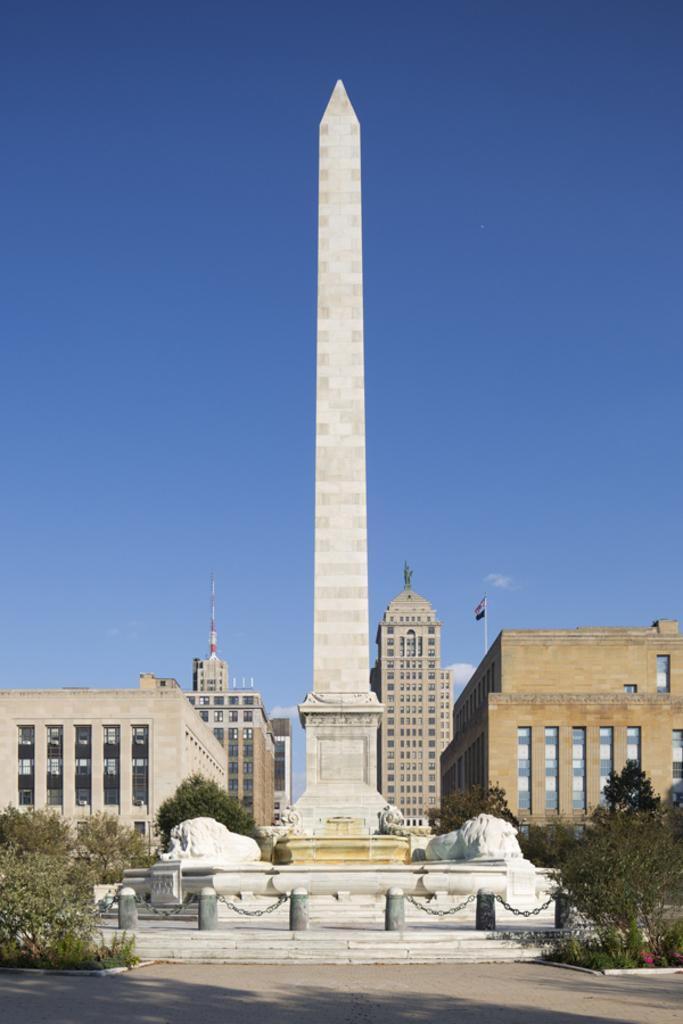What type of vegetation can be seen in the image? There are trees in the image. Where are the trees located in relation to other structures? The trees are in front of buildings. What is the main architectural feature in the middle of the image? There is a tower in the middle of the image. What can be seen in the distance behind the trees and buildings? There is a sky visible in the background of the image. What type of coil is wrapped around the trunk of the tree in the image? There is no coil present around the tree in the image. How many bulbs can be seen hanging from the branches of the trees? There are no bulbs visible on the trees in the image. 